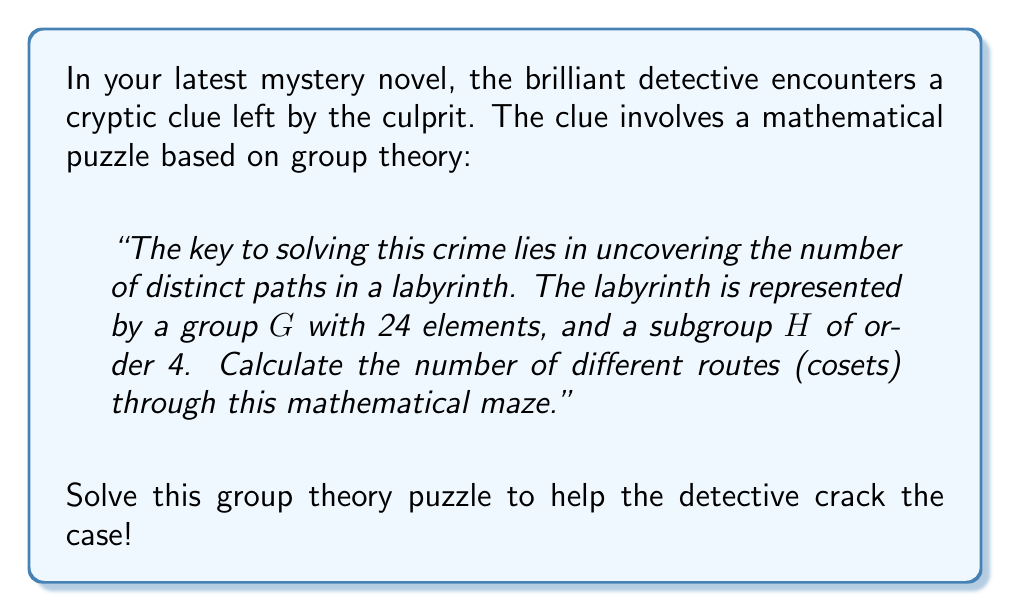Give your solution to this math problem. Let's approach this step-by-step:

1) First, recall the fundamental theorem of cosets: The number of left (or right) cosets of a subgroup $H$ in a group $G$ is equal to the index of $H$ in $G$, denoted as $[G:H]$.

2) The index $[G:H]$ is given by the formula:

   $$[G:H] = \frac{|G|}{|H|}$$

   where $|G|$ is the order of group $G$ and $|H|$ is the order of subgroup $H$.

3) We are given:
   - $|G| = 24$ (the group has 24 elements)
   - $|H| = 4$ (the subgroup has order 4)

4) Substituting these values into our formula:

   $$[G:H] = \frac{|G|}{|H|} = \frac{24}{4} = 6$$

5) Therefore, there are 6 distinct cosets of $H$ in $G$.

In the context of the detective's puzzle, this means there are 6 different "routes" through the mathematical labyrinth.
Answer: 6 cosets 